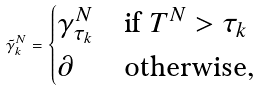Convert formula to latex. <formula><loc_0><loc_0><loc_500><loc_500>\tilde { \gamma } ^ { N } _ { k } = \begin{cases} \gamma ^ { N } _ { \tau _ { k } } & \text {if} \ T ^ { N } > \tau _ { k } \\ \partial & \text {otherwise} , \end{cases}</formula> 